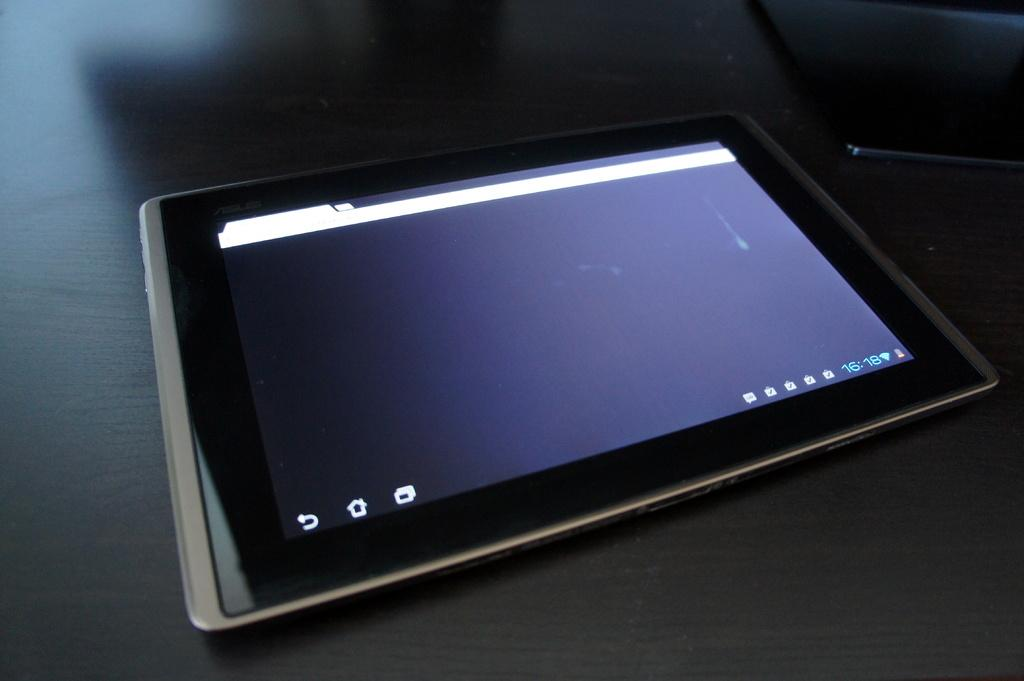What electronic device is visible in the image? There is a tablet with a screen in the image. Where is the tablet located? The tablet is placed on a desk surface. What type of dirt can be seen on the screen of the tablet in the image? There is no dirt visible on the screen of the tablet in the image. 